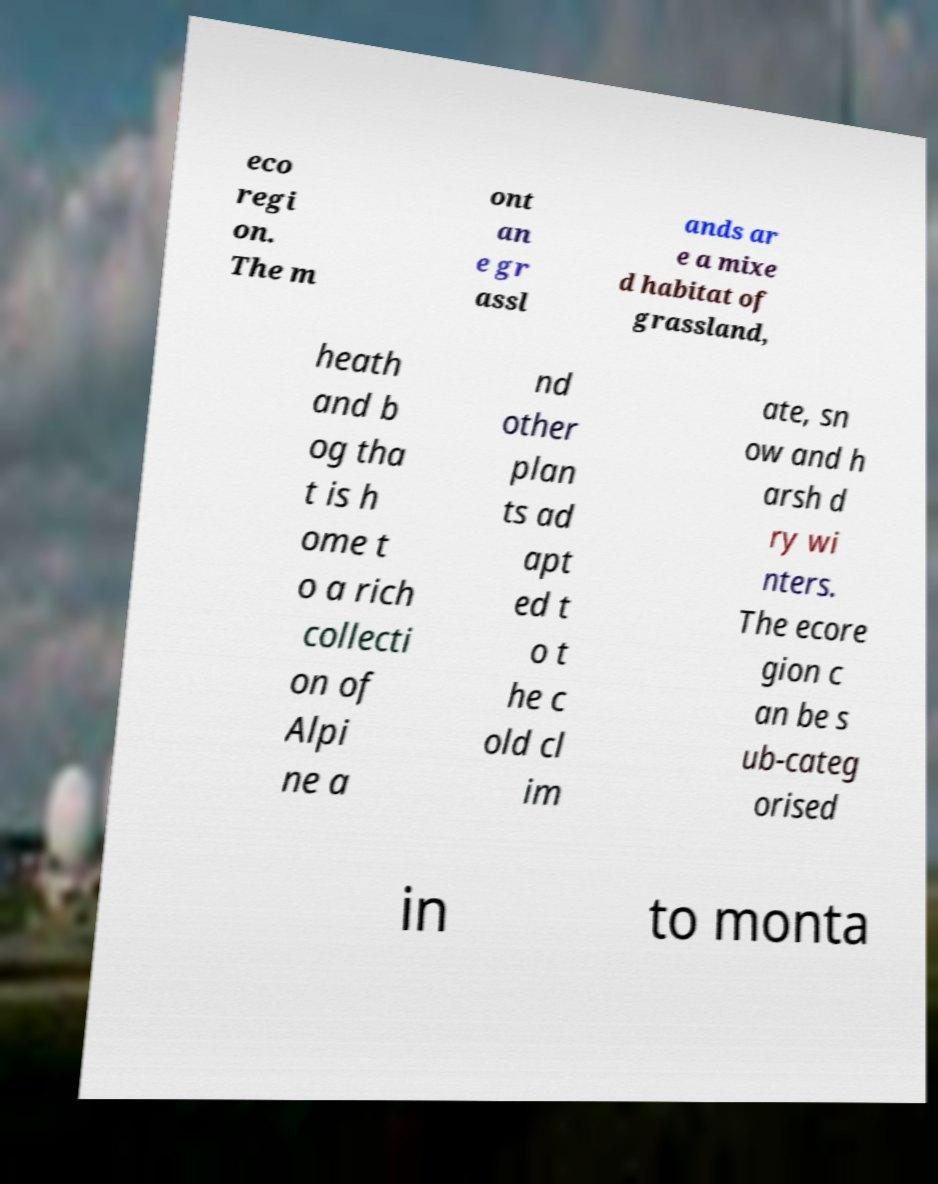What messages or text are displayed in this image? I need them in a readable, typed format. eco regi on. The m ont an e gr assl ands ar e a mixe d habitat of grassland, heath and b og tha t is h ome t o a rich collecti on of Alpi ne a nd other plan ts ad apt ed t o t he c old cl im ate, sn ow and h arsh d ry wi nters. The ecore gion c an be s ub-categ orised in to monta 